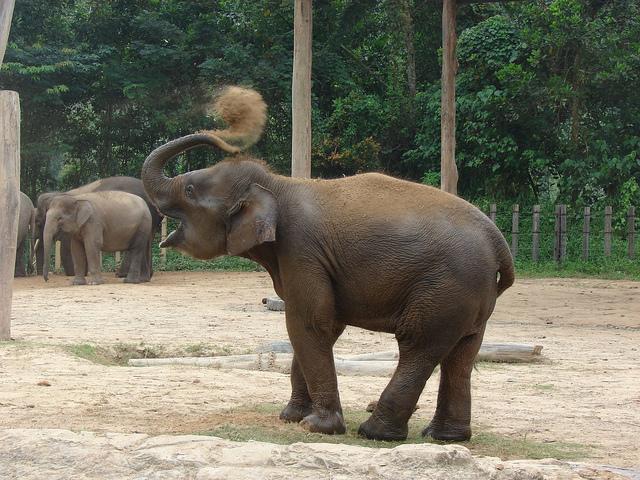How many elephants are visible?
Give a very brief answer. 3. 